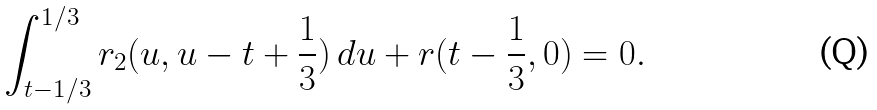<formula> <loc_0><loc_0><loc_500><loc_500>\int _ { t - 1 / 3 } ^ { 1 / 3 } r _ { 2 } ( u , u - t + \frac { 1 } { 3 } ) \, d u + r ( t - \frac { 1 } { 3 } , 0 ) = 0 .</formula> 